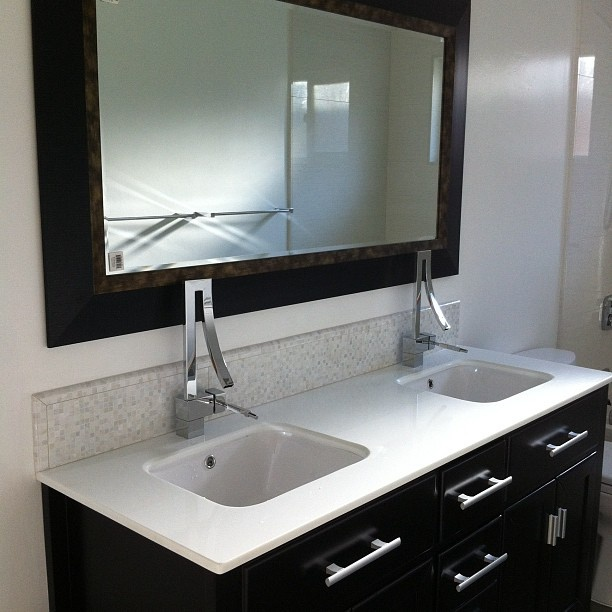Describe the objects in this image and their specific colors. I can see sink in darkgray and gray tones, sink in darkgray and gray tones, and toilet in darkgray and gray tones in this image. 